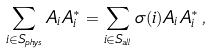<formula> <loc_0><loc_0><loc_500><loc_500>\sum _ { i \in S _ { p h y s } } A _ { i } A _ { i } ^ { * } = \sum _ { i \in S _ { a l l } } \sigma ( i ) A _ { i } A _ { i } ^ { * } \, ,</formula> 